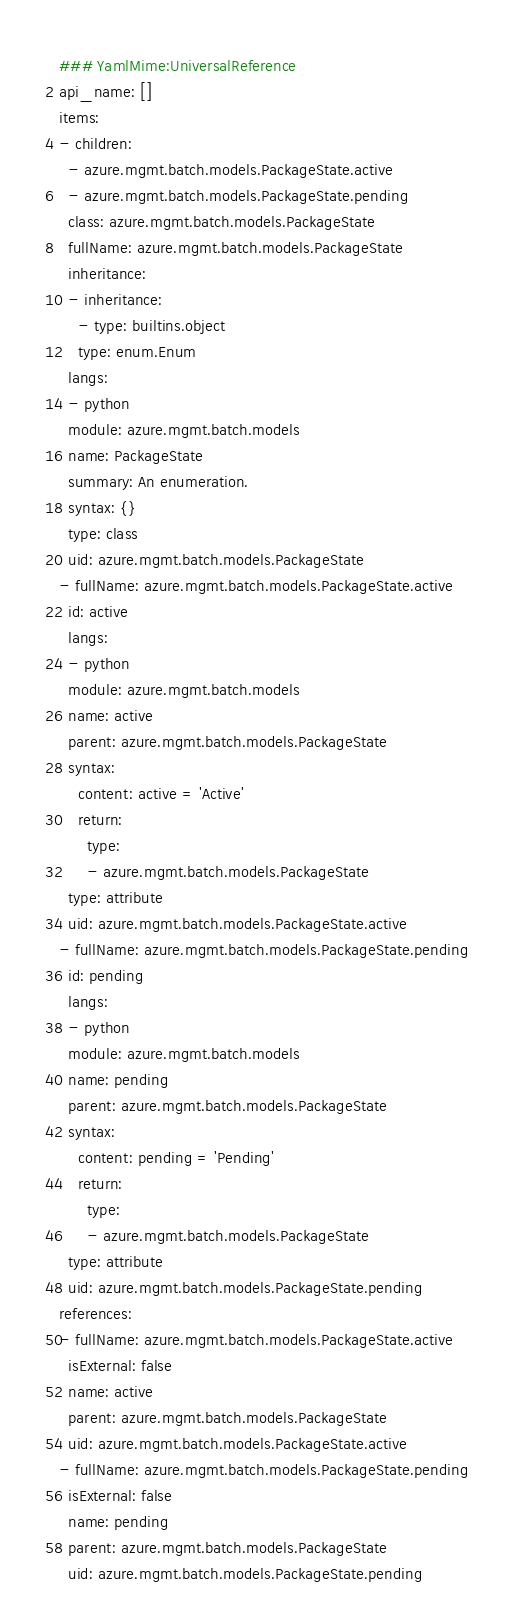Convert code to text. <code><loc_0><loc_0><loc_500><loc_500><_YAML_>### YamlMime:UniversalReference
api_name: []
items:
- children:
  - azure.mgmt.batch.models.PackageState.active
  - azure.mgmt.batch.models.PackageState.pending
  class: azure.mgmt.batch.models.PackageState
  fullName: azure.mgmt.batch.models.PackageState
  inheritance:
  - inheritance:
    - type: builtins.object
    type: enum.Enum
  langs:
  - python
  module: azure.mgmt.batch.models
  name: PackageState
  summary: An enumeration.
  syntax: {}
  type: class
  uid: azure.mgmt.batch.models.PackageState
- fullName: azure.mgmt.batch.models.PackageState.active
  id: active
  langs:
  - python
  module: azure.mgmt.batch.models
  name: active
  parent: azure.mgmt.batch.models.PackageState
  syntax:
    content: active = 'Active'
    return:
      type:
      - azure.mgmt.batch.models.PackageState
  type: attribute
  uid: azure.mgmt.batch.models.PackageState.active
- fullName: azure.mgmt.batch.models.PackageState.pending
  id: pending
  langs:
  - python
  module: azure.mgmt.batch.models
  name: pending
  parent: azure.mgmt.batch.models.PackageState
  syntax:
    content: pending = 'Pending'
    return:
      type:
      - azure.mgmt.batch.models.PackageState
  type: attribute
  uid: azure.mgmt.batch.models.PackageState.pending
references:
- fullName: azure.mgmt.batch.models.PackageState.active
  isExternal: false
  name: active
  parent: azure.mgmt.batch.models.PackageState
  uid: azure.mgmt.batch.models.PackageState.active
- fullName: azure.mgmt.batch.models.PackageState.pending
  isExternal: false
  name: pending
  parent: azure.mgmt.batch.models.PackageState
  uid: azure.mgmt.batch.models.PackageState.pending
</code> 